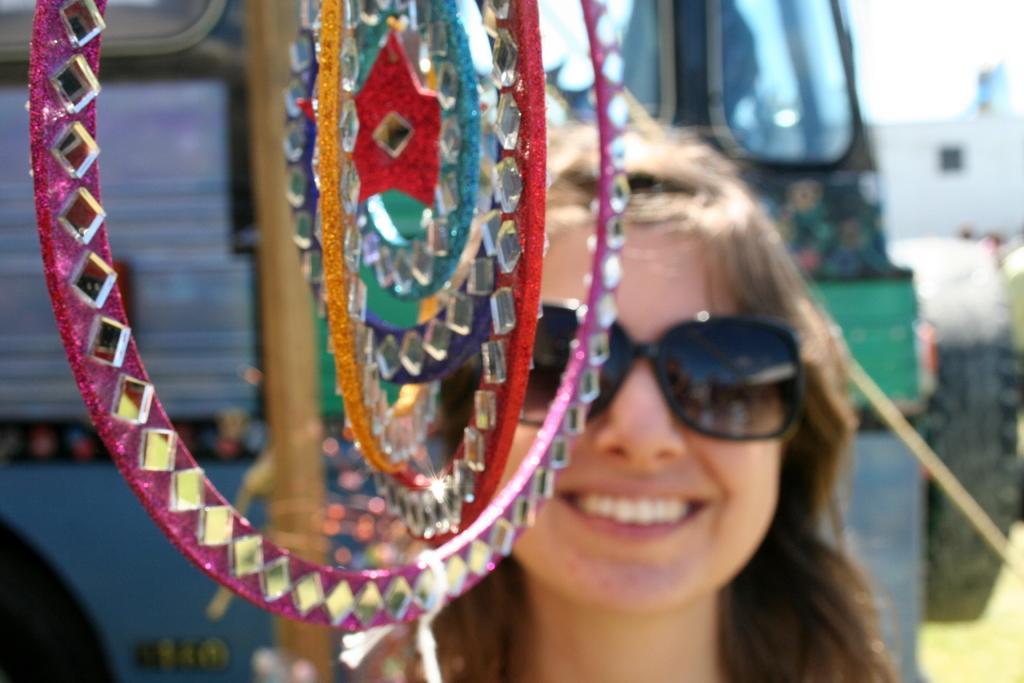Please provide a concise description of this image. In this image there is a woman smiling, in front of the woman there is some object, behind the woman there is a bus. 